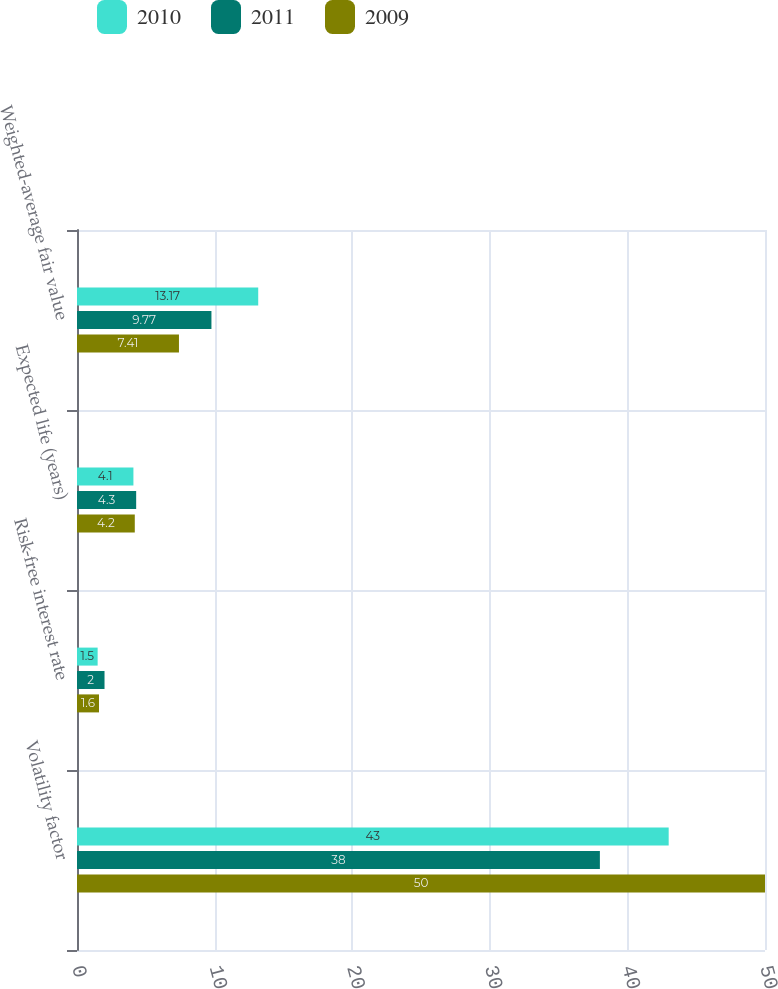Convert chart. <chart><loc_0><loc_0><loc_500><loc_500><stacked_bar_chart><ecel><fcel>Volatility factor<fcel>Risk-free interest rate<fcel>Expected life (years)<fcel>Weighted-average fair value<nl><fcel>2010<fcel>43<fcel>1.5<fcel>4.1<fcel>13.17<nl><fcel>2011<fcel>38<fcel>2<fcel>4.3<fcel>9.77<nl><fcel>2009<fcel>50<fcel>1.6<fcel>4.2<fcel>7.41<nl></chart> 